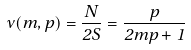<formula> <loc_0><loc_0><loc_500><loc_500>\nu ( m , p ) = \frac { N } { 2 S } = \frac { p } { 2 m p + 1 }</formula> 